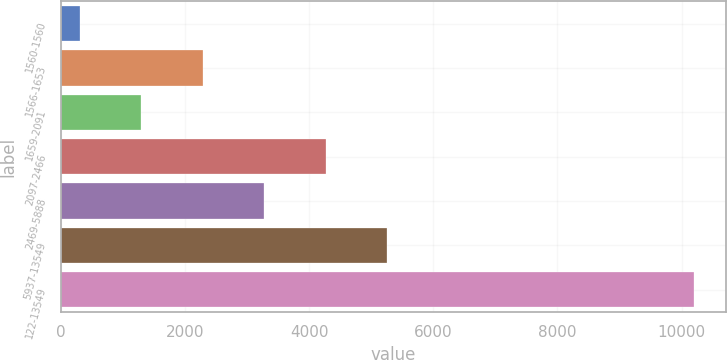<chart> <loc_0><loc_0><loc_500><loc_500><bar_chart><fcel>1560-1560<fcel>1566-1653<fcel>1659-2091<fcel>2097-2466<fcel>2469-5888<fcel>5937-13549<fcel>122-13549<nl><fcel>307<fcel>2286.6<fcel>1296.8<fcel>4266.2<fcel>3276.4<fcel>5256<fcel>10205<nl></chart> 